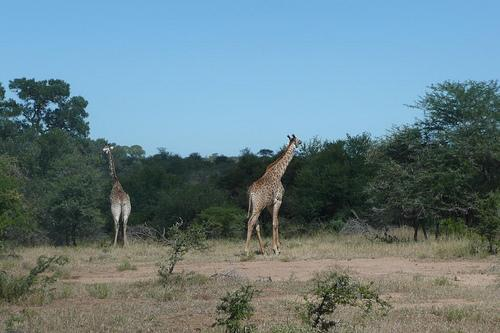Based on the descriptions provided about the giraffes in the image, can you determine their age and direction they're facing? One giraffe is an adult facing right and the other is an adult facing away from the viewer. Give a brief summary of the scene depicted in the image. The image shows two giraffes in an open field, looking for food with trees and a small tree in a distance, under a clear blue sky. Can you identify the object in the center of the photo and its state? There is a large shrub in the center of the photo, which appears to be dead. Enumerate the objects in the image, and provide the overall sentiment it projects. Objects: two giraffes, trees, bushes, grass, sky, small tree. The image conveys a calm and peaceful sentiment in a natural environment. Based on the object descriptions given, what time of day is it likely to be? It is likely daytime, as the sky is clear and blue. Analyze the quality of the image in terms of visual clarity and detail. The image quality appears to be high, with good visual clarity and detailed object descriptions. What is the condition of the grass on the ground and what is growing amongst it? The grass is patchy and brown, with weeds and dead, dying grass growing in it. How many trees and bushes are present in the scene and where are they located? There is a cluster of low trees on the right, large green trees on the left, two bushes growing in the desert, and one large dead tree branch. How many giraffes are in the image, and what are they doing? There are two giraffes in the image, roaming and looking for food. Identify the predominant color of the sky in the image and describe its appearance. The sky is blue and clear, indicating a bright day with no clouds in sight. What type of event is occurring in the image related to the giraffes? Two giraffes are roaming and looking for food in a field Can you identify and describe the objects related to the vegetation in the image? Trees, weeds, grass, bushes, and a small tree in a field Are there any diagrams included in the image? No diagrams are present in the image What color is the sky in the image? Blue In which direction is the adult giraffe facing?  Right Is it day or night time in the image? It is day time What activity are two giraffes doing in the image? Roaming and looking for food Describe the state of the grass in the image. Patchy with dying and dead parts, and weeds growing Identify and describe the tree-covered hill in the image. A tree-covered hill is rising in the distance Which giraffe specie are depicted in the image? It's not possible to determine the species from the information provided. How many shrubs are growing in the desert part of the image? Two Which option best describes what the sky looks like in the image? Answer: Which image caption accurately describes the scene with giraffes and vegetation? b) Two giraffes walking into the woods How many legs does a giraffe have in the image? Four Describe the condition of the ground. The ground is brown and covered in patchy grass Identify the large dead tree part mentioned in the image's information. A large dead tree branch Create a brief story using the elements present in the image. On a beautiful, cloudless day, two giraffes roamed a vast open field, looking for food among the patchy grass and small trees that dotted the landscape. In the distance, a tree-covered hill rose against the backdrop of the clear blue sky, providing shelter to various animals including the giraffes. What kind of vegetation is dead center of the photo? A large shrub Describe where the large green trees are located in the image. On the left 